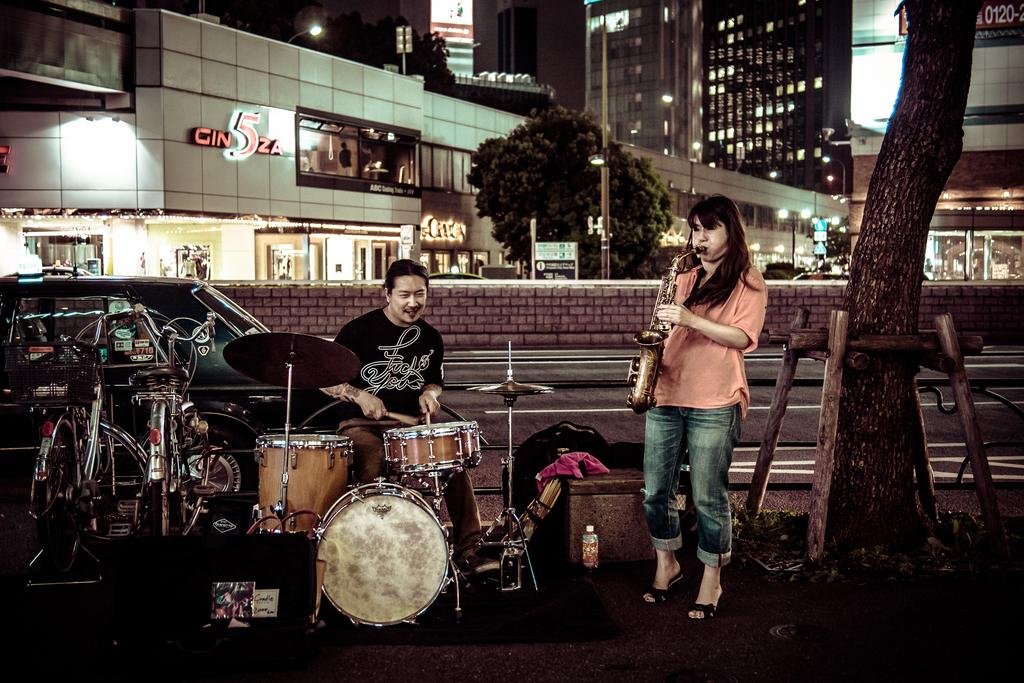What is the woman in the image doing? The woman is playing a Saxophone in the image. What is the other person in the image doing? There is a person playing drums in the image. What objects are beside the person playing drums? There are two cycles beside the person playing drums. What can be seen in the background of the image? Buildings and trees are visible in the background of the image. What type of crib is visible in the image? There is no crib present in the image. What instrument is the woman playing in the image? The woman is playing a Saxophone in the image. 